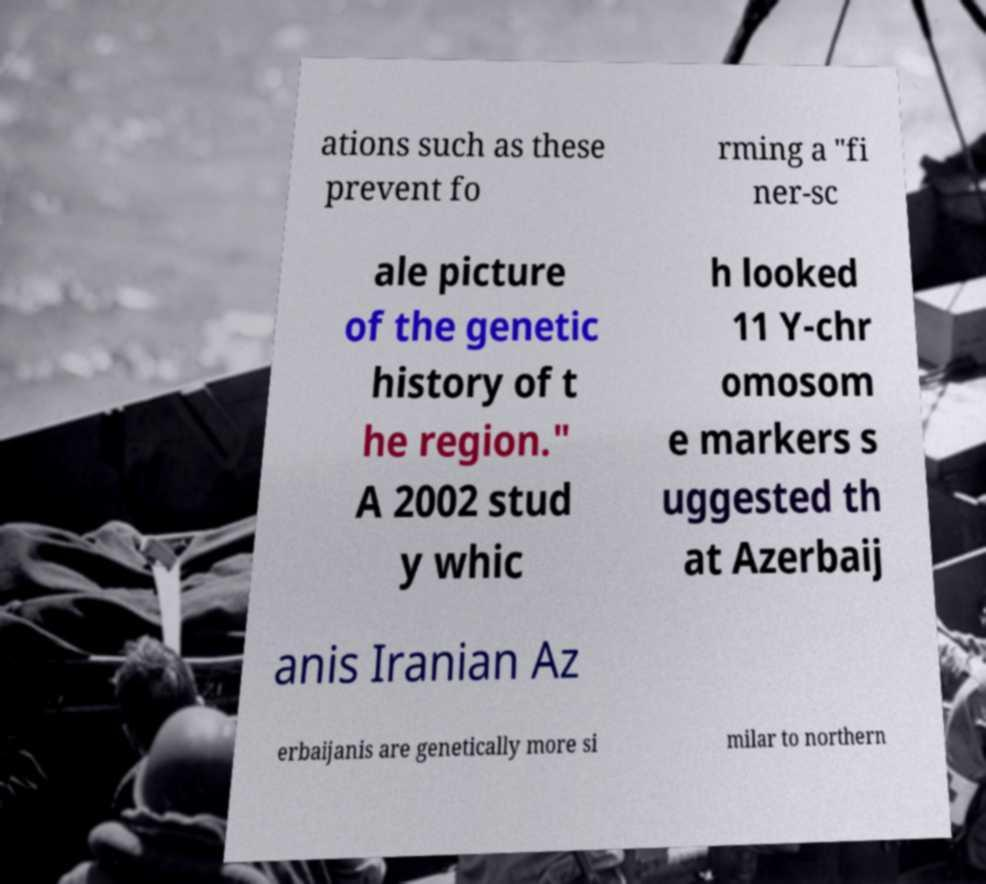For documentation purposes, I need the text within this image transcribed. Could you provide that? ations such as these prevent fo rming a "fi ner-sc ale picture of the genetic history of t he region." A 2002 stud y whic h looked 11 Y-chr omosom e markers s uggested th at Azerbaij anis Iranian Az erbaijanis are genetically more si milar to northern 